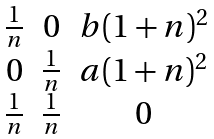<formula> <loc_0><loc_0><loc_500><loc_500>\begin{matrix} \frac { 1 } { n } & 0 & b ( 1 + n ) ^ { 2 } \\ 0 & \frac { 1 } { n } & a ( 1 + n ) ^ { 2 } \\ \frac { 1 } { n } & \frac { 1 } { n } & 0 \end{matrix}</formula> 